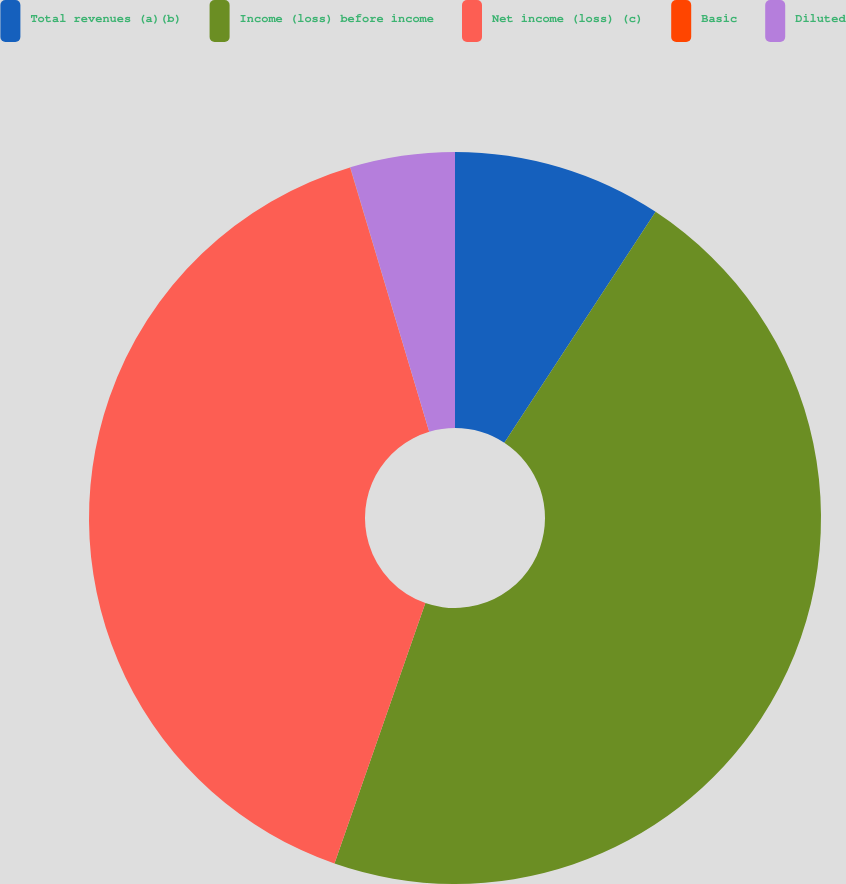<chart> <loc_0><loc_0><loc_500><loc_500><pie_chart><fcel>Total revenues (a)(b)<fcel>Income (loss) before income<fcel>Net income (loss) (c)<fcel>Basic<fcel>Diluted<nl><fcel>9.23%<fcel>46.1%<fcel>40.02%<fcel>0.01%<fcel>4.62%<nl></chart> 